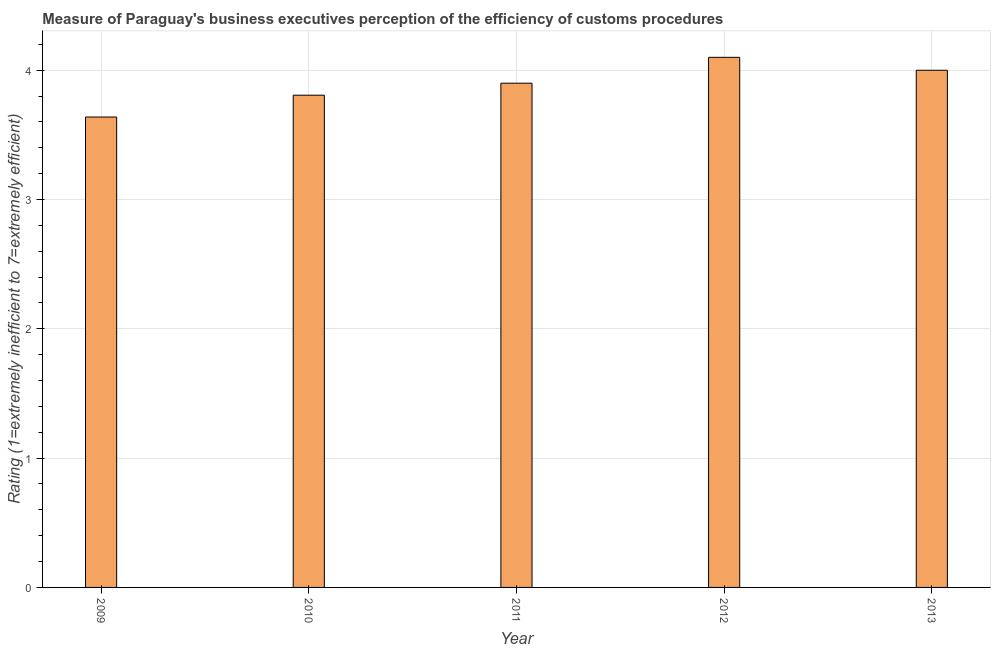Does the graph contain any zero values?
Provide a short and direct response. No. What is the title of the graph?
Keep it short and to the point. Measure of Paraguay's business executives perception of the efficiency of customs procedures. What is the label or title of the X-axis?
Your answer should be compact. Year. What is the label or title of the Y-axis?
Offer a terse response. Rating (1=extremely inefficient to 7=extremely efficient). What is the rating measuring burden of customs procedure in 2010?
Provide a succinct answer. 3.81. Across all years, what is the maximum rating measuring burden of customs procedure?
Your response must be concise. 4.1. Across all years, what is the minimum rating measuring burden of customs procedure?
Provide a short and direct response. 3.64. In which year was the rating measuring burden of customs procedure minimum?
Ensure brevity in your answer.  2009. What is the sum of the rating measuring burden of customs procedure?
Give a very brief answer. 19.45. What is the difference between the rating measuring burden of customs procedure in 2012 and 2013?
Ensure brevity in your answer.  0.1. What is the average rating measuring burden of customs procedure per year?
Provide a succinct answer. 3.89. What is the median rating measuring burden of customs procedure?
Ensure brevity in your answer.  3.9. In how many years, is the rating measuring burden of customs procedure greater than 1.6 ?
Ensure brevity in your answer.  5. Do a majority of the years between 2010 and 2012 (inclusive) have rating measuring burden of customs procedure greater than 2.8 ?
Ensure brevity in your answer.  Yes. What is the ratio of the rating measuring burden of customs procedure in 2011 to that in 2013?
Provide a succinct answer. 0.97. Is the rating measuring burden of customs procedure in 2010 less than that in 2011?
Your response must be concise. Yes. Is the difference between the rating measuring burden of customs procedure in 2011 and 2013 greater than the difference between any two years?
Provide a succinct answer. No. What is the difference between the highest and the second highest rating measuring burden of customs procedure?
Your answer should be compact. 0.1. Is the sum of the rating measuring burden of customs procedure in 2012 and 2013 greater than the maximum rating measuring burden of customs procedure across all years?
Offer a very short reply. Yes. What is the difference between the highest and the lowest rating measuring burden of customs procedure?
Ensure brevity in your answer.  0.46. How many bars are there?
Your answer should be very brief. 5. Are all the bars in the graph horizontal?
Ensure brevity in your answer.  No. What is the Rating (1=extremely inefficient to 7=extremely efficient) of 2009?
Offer a very short reply. 3.64. What is the Rating (1=extremely inefficient to 7=extremely efficient) in 2010?
Your response must be concise. 3.81. What is the Rating (1=extremely inefficient to 7=extremely efficient) in 2013?
Make the answer very short. 4. What is the difference between the Rating (1=extremely inefficient to 7=extremely efficient) in 2009 and 2010?
Provide a short and direct response. -0.17. What is the difference between the Rating (1=extremely inefficient to 7=extremely efficient) in 2009 and 2011?
Ensure brevity in your answer.  -0.26. What is the difference between the Rating (1=extremely inefficient to 7=extremely efficient) in 2009 and 2012?
Offer a terse response. -0.46. What is the difference between the Rating (1=extremely inefficient to 7=extremely efficient) in 2009 and 2013?
Keep it short and to the point. -0.36. What is the difference between the Rating (1=extremely inefficient to 7=extremely efficient) in 2010 and 2011?
Your response must be concise. -0.09. What is the difference between the Rating (1=extremely inefficient to 7=extremely efficient) in 2010 and 2012?
Make the answer very short. -0.29. What is the difference between the Rating (1=extremely inefficient to 7=extremely efficient) in 2010 and 2013?
Give a very brief answer. -0.19. What is the difference between the Rating (1=extremely inefficient to 7=extremely efficient) in 2011 and 2013?
Give a very brief answer. -0.1. What is the ratio of the Rating (1=extremely inefficient to 7=extremely efficient) in 2009 to that in 2010?
Give a very brief answer. 0.96. What is the ratio of the Rating (1=extremely inefficient to 7=extremely efficient) in 2009 to that in 2011?
Make the answer very short. 0.93. What is the ratio of the Rating (1=extremely inefficient to 7=extremely efficient) in 2009 to that in 2012?
Offer a terse response. 0.89. What is the ratio of the Rating (1=extremely inefficient to 7=extremely efficient) in 2009 to that in 2013?
Provide a succinct answer. 0.91. What is the ratio of the Rating (1=extremely inefficient to 7=extremely efficient) in 2010 to that in 2011?
Offer a terse response. 0.98. What is the ratio of the Rating (1=extremely inefficient to 7=extremely efficient) in 2010 to that in 2012?
Your response must be concise. 0.93. What is the ratio of the Rating (1=extremely inefficient to 7=extremely efficient) in 2011 to that in 2012?
Keep it short and to the point. 0.95. What is the ratio of the Rating (1=extremely inefficient to 7=extremely efficient) in 2011 to that in 2013?
Give a very brief answer. 0.97. What is the ratio of the Rating (1=extremely inefficient to 7=extremely efficient) in 2012 to that in 2013?
Ensure brevity in your answer.  1.02. 